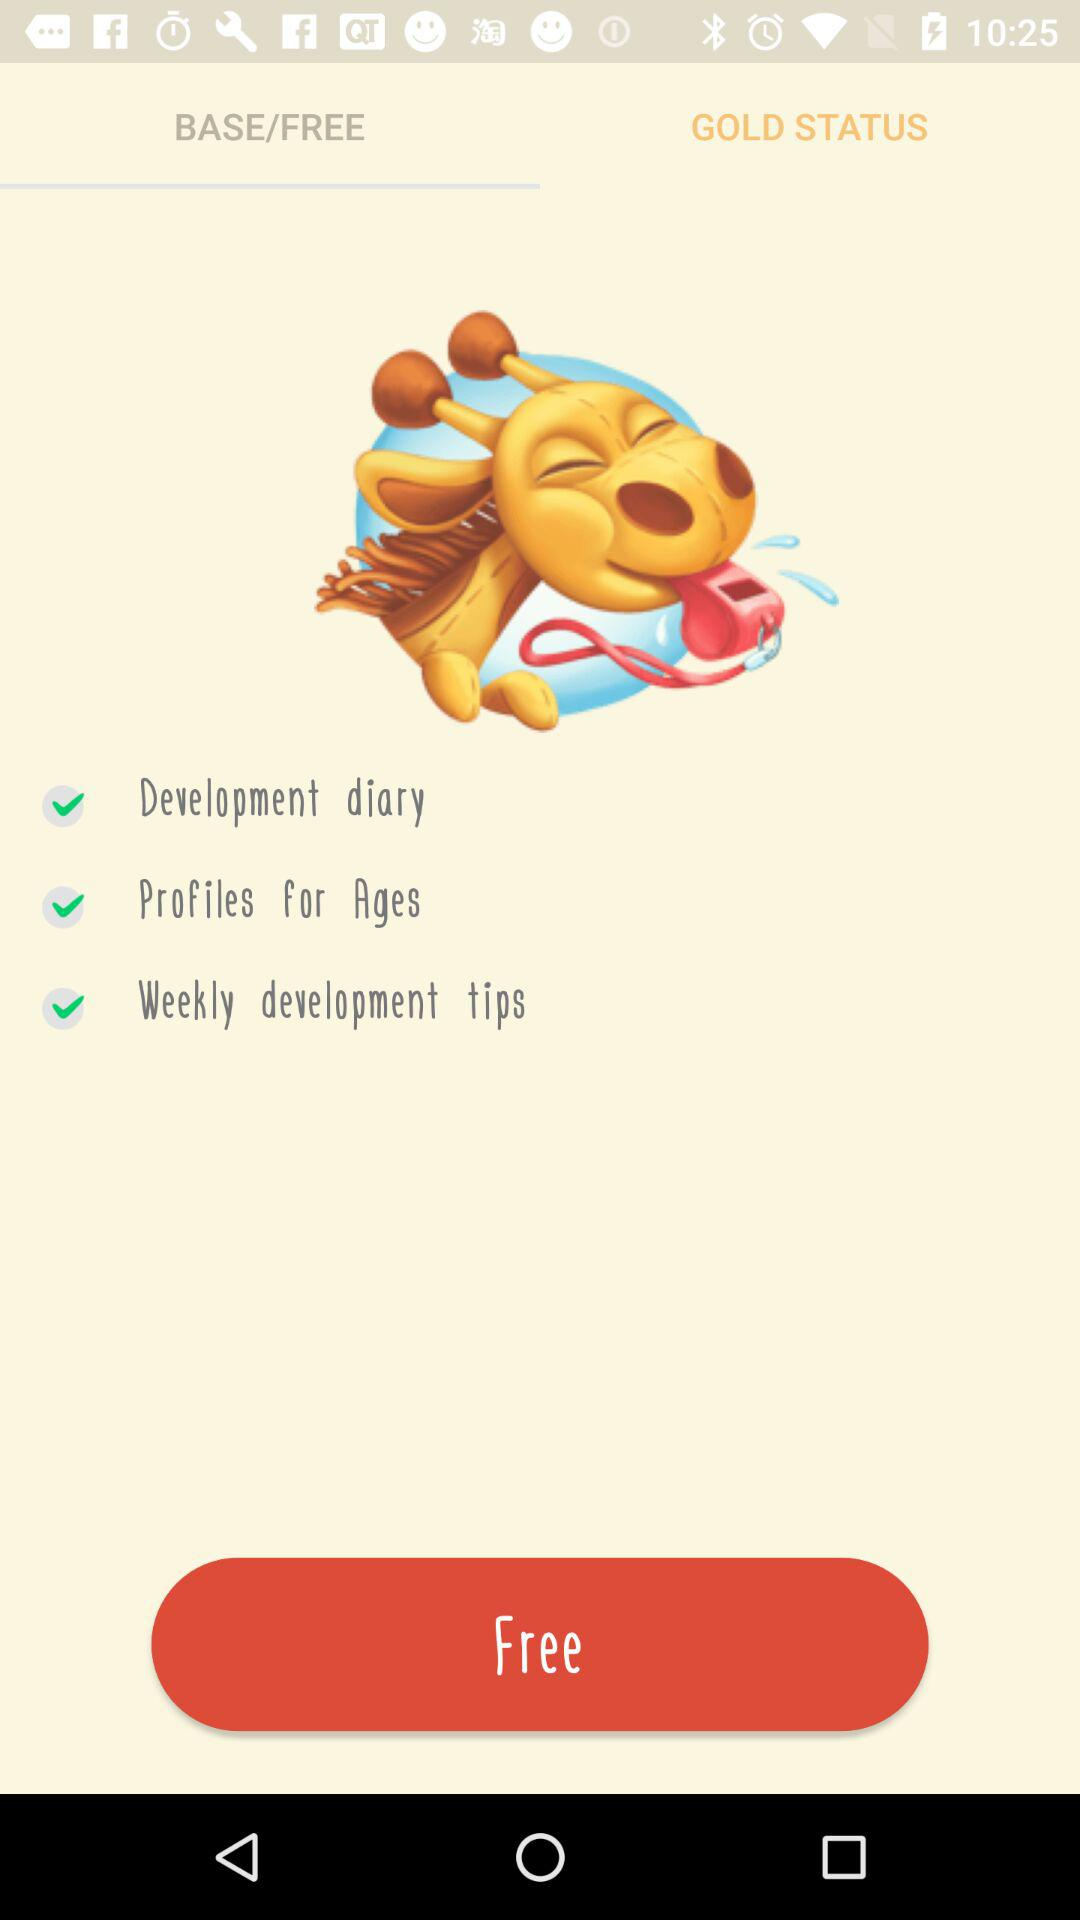Which tab is selected? The selected tab is "BASE/FREE". 